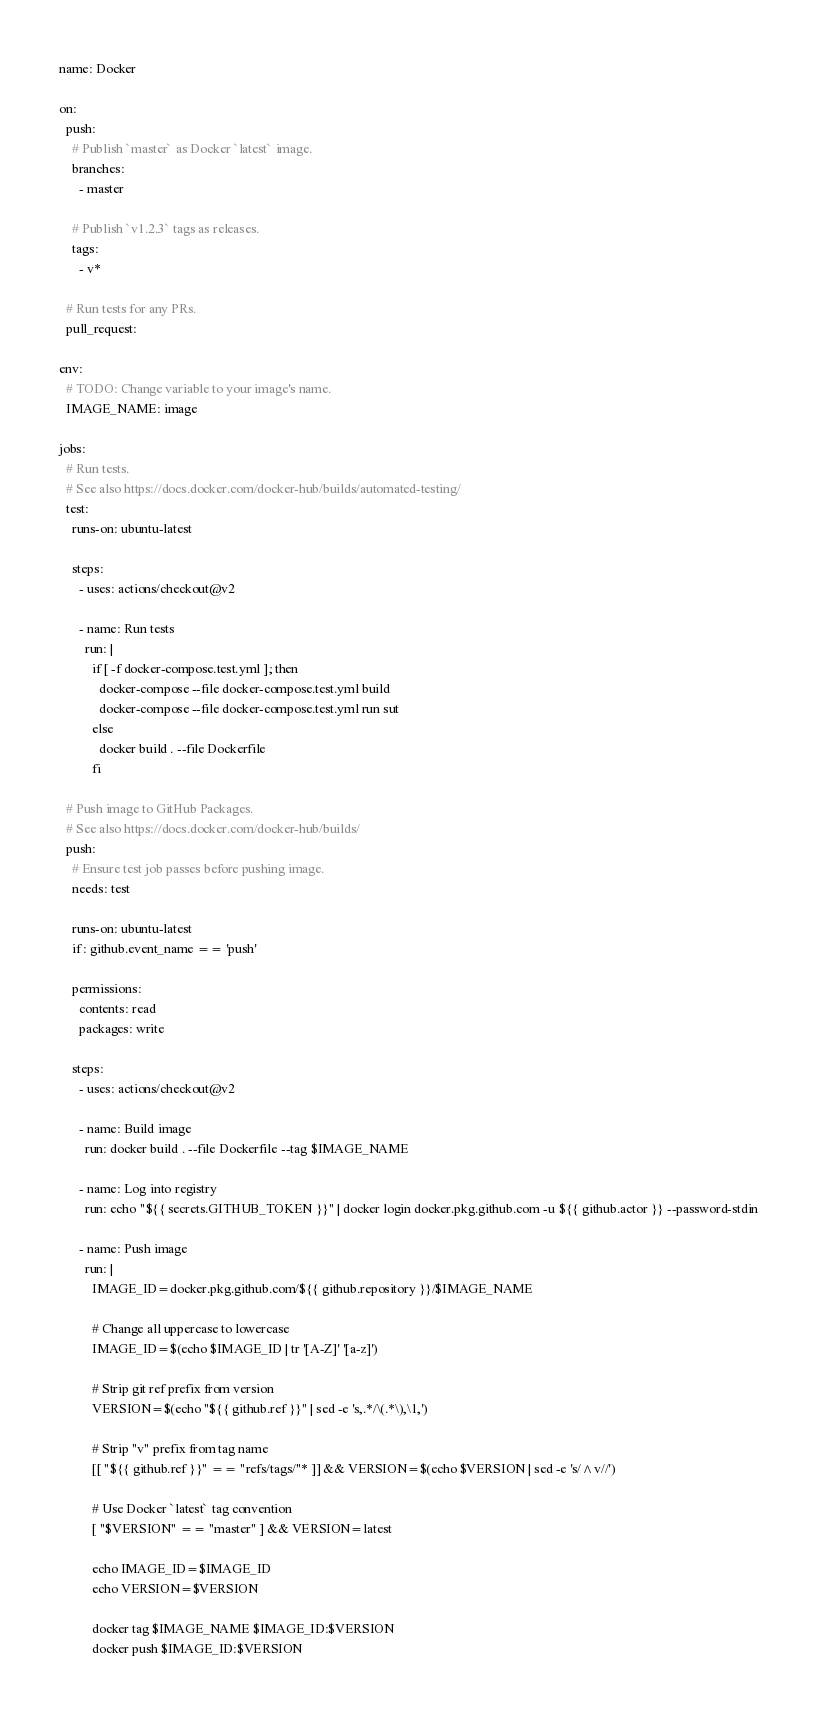<code> <loc_0><loc_0><loc_500><loc_500><_YAML_>name: Docker

on:
  push:
    # Publish `master` as Docker `latest` image.
    branches:
      - master

    # Publish `v1.2.3` tags as releases.
    tags:
      - v*

  # Run tests for any PRs.
  pull_request:

env:
  # TODO: Change variable to your image's name.
  IMAGE_NAME: image

jobs:
  # Run tests.
  # See also https://docs.docker.com/docker-hub/builds/automated-testing/
  test:
    runs-on: ubuntu-latest

    steps:
      - uses: actions/checkout@v2

      - name: Run tests
        run: |
          if [ -f docker-compose.test.yml ]; then
            docker-compose --file docker-compose.test.yml build
            docker-compose --file docker-compose.test.yml run sut
          else
            docker build . --file Dockerfile
          fi

  # Push image to GitHub Packages.
  # See also https://docs.docker.com/docker-hub/builds/
  push:
    # Ensure test job passes before pushing image.
    needs: test

    runs-on: ubuntu-latest
    if: github.event_name == 'push'

    permissions:
      contents: read
      packages: write

    steps:
      - uses: actions/checkout@v2

      - name: Build image
        run: docker build . --file Dockerfile --tag $IMAGE_NAME

      - name: Log into registry
        run: echo "${{ secrets.GITHUB_TOKEN }}" | docker login docker.pkg.github.com -u ${{ github.actor }} --password-stdin

      - name: Push image
        run: |
          IMAGE_ID=docker.pkg.github.com/${{ github.repository }}/$IMAGE_NAME

          # Change all uppercase to lowercase
          IMAGE_ID=$(echo $IMAGE_ID | tr '[A-Z]' '[a-z]')

          # Strip git ref prefix from version
          VERSION=$(echo "${{ github.ref }}" | sed -e 's,.*/\(.*\),\1,')

          # Strip "v" prefix from tag name
          [[ "${{ github.ref }}" == "refs/tags/"* ]] && VERSION=$(echo $VERSION | sed -e 's/^v//')

          # Use Docker `latest` tag convention
          [ "$VERSION" == "master" ] && VERSION=latest

          echo IMAGE_ID=$IMAGE_ID
          echo VERSION=$VERSION

          docker tag $IMAGE_NAME $IMAGE_ID:$VERSION
          docker push $IMAGE_ID:$VERSION
</code> 